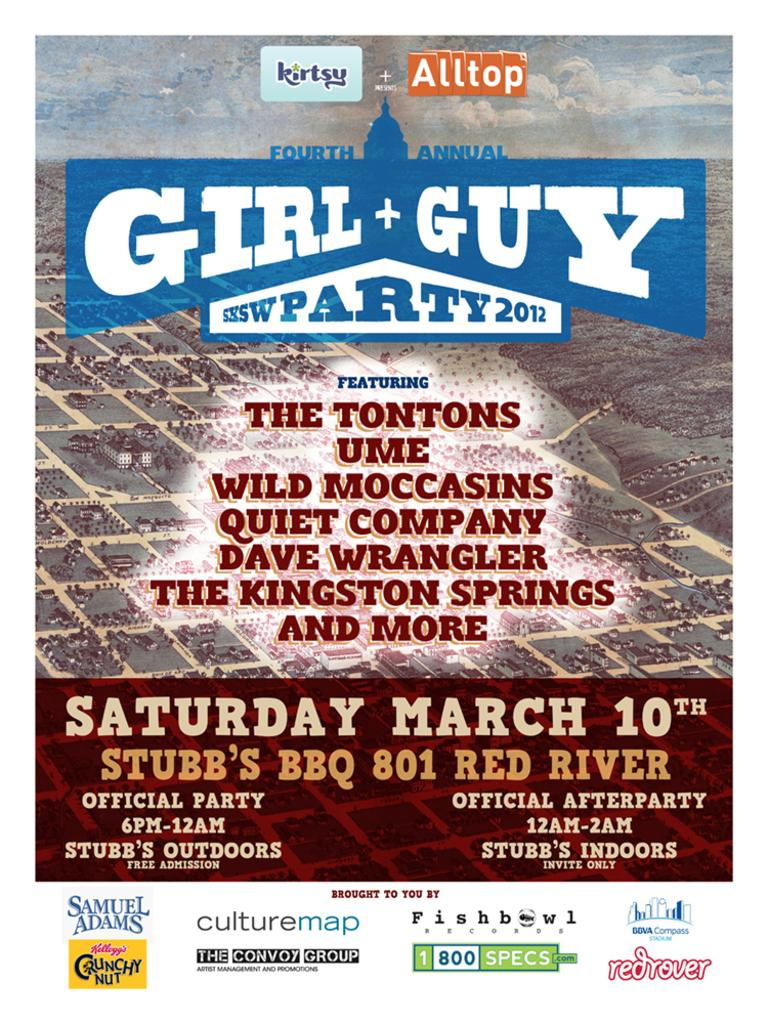Provide a one-sentence caption for the provided image. A busy poster for a party in March featuring a number of acts from 2012. 